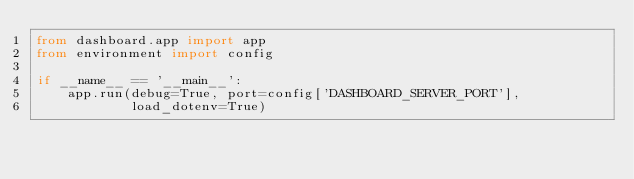Convert code to text. <code><loc_0><loc_0><loc_500><loc_500><_Python_>from dashboard.app import app
from environment import config

if __name__ == '__main__':
    app.run(debug=True, port=config['DASHBOARD_SERVER_PORT'],
            load_dotenv=True)
</code> 